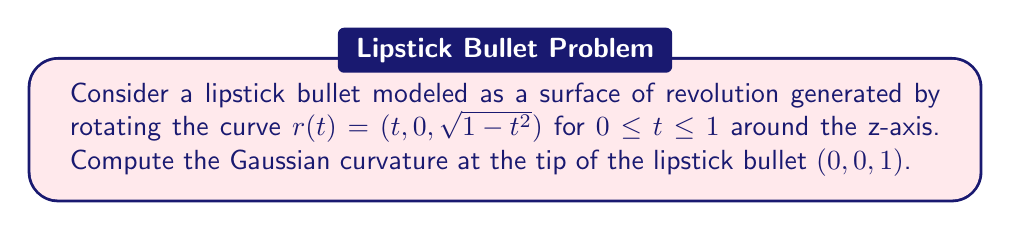Help me with this question. To compute the Gaussian curvature, we'll follow these steps:

1) First, we need to parametrize the surface. Let $\phi$ be the angle of rotation around the z-axis. The parametrization is:

   $x(t,\phi) = (t\cos\phi, t\sin\phi, \sqrt{1-t^2})$

2) Calculate the partial derivatives:
   $x_t = (\cos\phi, \sin\phi, -t/\sqrt{1-t^2})$
   $x_\phi = (-t\sin\phi, t\cos\phi, 0)$

3) Calculate the coefficients of the first fundamental form:
   $E = x_t \cdot x_t = 1 + \frac{t^2}{1-t^2}$
   $F = x_t \cdot x_\phi = 0$
   $G = x_\phi \cdot x_\phi = t^2$

4) Calculate the unit normal vector:
   $N = \frac{x_t \times x_\phi}{|x_t \times x_\phi|} = (-\cos\phi\sqrt{1-t^2}, -\sin\phi\sqrt{1-t^2}, -t)$

5) Calculate the second partial derivatives:
   $x_{tt} = (0, 0, -1/(1-t^2)^{3/2})$
   $x_{t\phi} = (-\sin\phi, \cos\phi, 0)$
   $x_{\phi\phi} = (-t\cos\phi, -t\sin\phi, 0)$

6) Calculate the coefficients of the second fundamental form:
   $e = x_{tt} \cdot N = \frac{1}{\sqrt{1-t^2}}$
   $f = x_{t\phi} \cdot N = 0$
   $g = x_{\phi\phi} \cdot N = t\sqrt{1-t^2}$

7) The Gaussian curvature is given by:
   $K = \frac{eg-f^2}{EG-F^2}$

8) Substituting the values at the tip $(t=0)$:
   $K = \frac{(1)(0) - 0^2}{(1)(0) - 0^2} = \frac{0}{0}$

9) This is an indeterminate form. We need to use L'Hôpital's rule:
   $\lim_{t\to 0} K = \lim_{t\to 0} \frac{eg-f^2}{EG-F^2} = \lim_{t\to 0} \frac{\frac{d}{dt}(eg-f^2)}{\frac{d}{dt}(EG-F^2)}$

10) Calculating the derivatives:
    $\frac{d}{dt}(eg-f^2) = \frac{d}{dt}(t(1-t^2)) = 1-3t^2$
    $\frac{d}{dt}(EG-F^2) = \frac{d}{dt}(t^2(1+\frac{t^2}{1-t^2})) = 2t+\frac{2t^3}{(1-t^2)^2}$

11) Taking the limit:
    $\lim_{t\to 0} K = \frac{1-3(0)^2}{2(0)+\frac{2(0)^3}{(1-(0)^2)^2}} = \frac{1}{0}$

Therefore, the Gaussian curvature at the tip of the lipstick bullet is infinite.
Answer: $K = \infty$ 